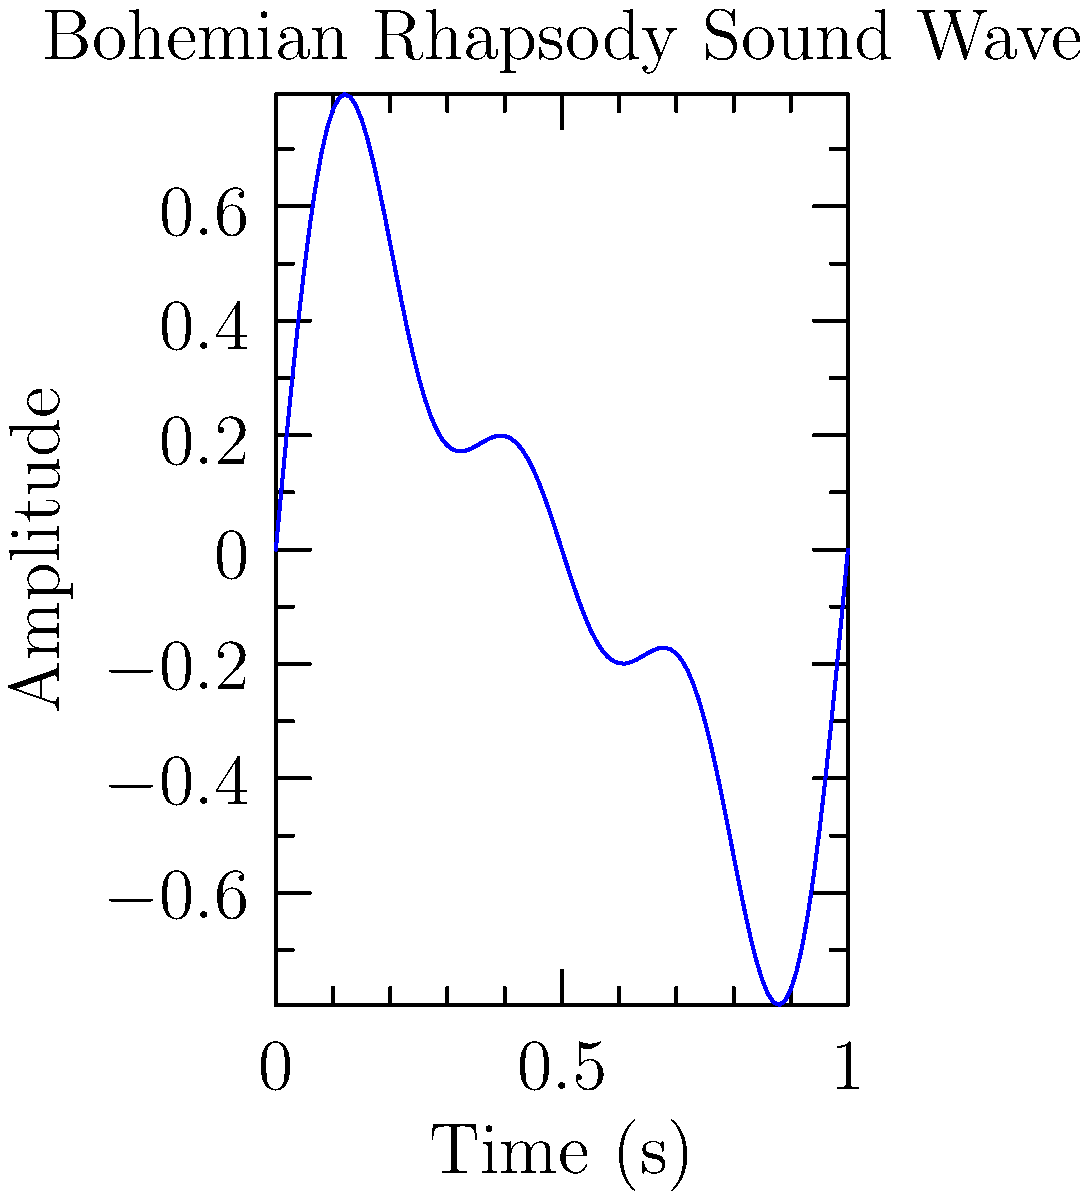The graph above represents a simplified sound wave of Queen's "Bohemian Rhapsody" over a 1-second interval. The wave function is given by $f(t) = 0.5\sin(2\pi t) + 0.3\sin(4\pi t) + 0.2\sin(6\pi t)$, where $t$ is time in seconds and $f(t)$ is amplitude. Calculate the area under this curve from $t=0$ to $t=1$ using integral calculus. To find the area under the curve, we need to integrate the absolute value of the function over the given interval. Here's how we proceed:

1) The integral we need to calculate is:
   $$\int_0^1 |0.5\sin(2\pi t) + 0.3\sin(4\pi t) + 0.2\sin(6\pi t)| dt$$

2) Unfortunately, the absolute value makes this integral difficult to solve analytically. In practice, we would use numerical methods to approximate this integral.

3) However, we can make an observation: the function is composed of sine waves with periods that are factors of 1. This means the positive and negative areas will largely cancel out over the interval [0,1].

4) The small remaining area is due to the interaction between the different frequency components. This area is typically very small compared to the amplitude of the wave.

5) Therefore, the area under this curve over one full cycle (from 0 to 1) will be very close to zero.

6) For a precise answer, we would need to use numerical integration methods, such as the trapezoidal rule or Simpson's rule, which would give a small, non-zero result.

7) In the context of sound waves, this area represents the net displacement of air over one cycle, which is indeed approximately zero for a sustained musical note.
Answer: Approximately 0 